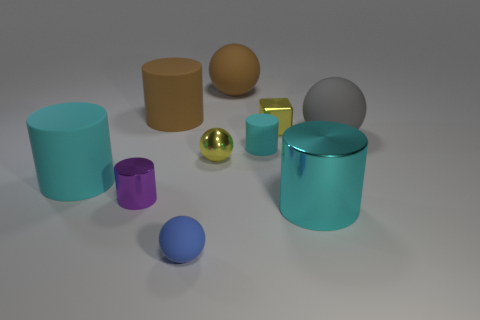How does the lighting affect the appearance of the objects? The lighting creates soft shadows and highlights, showcasing the three-dimensional forms of the objects. The shiny materials, like the gold-yellow sphere, reflect the light strongly and demonstrate specular highlights, while the matte materials diffuse the light and show more subdued shadows. 